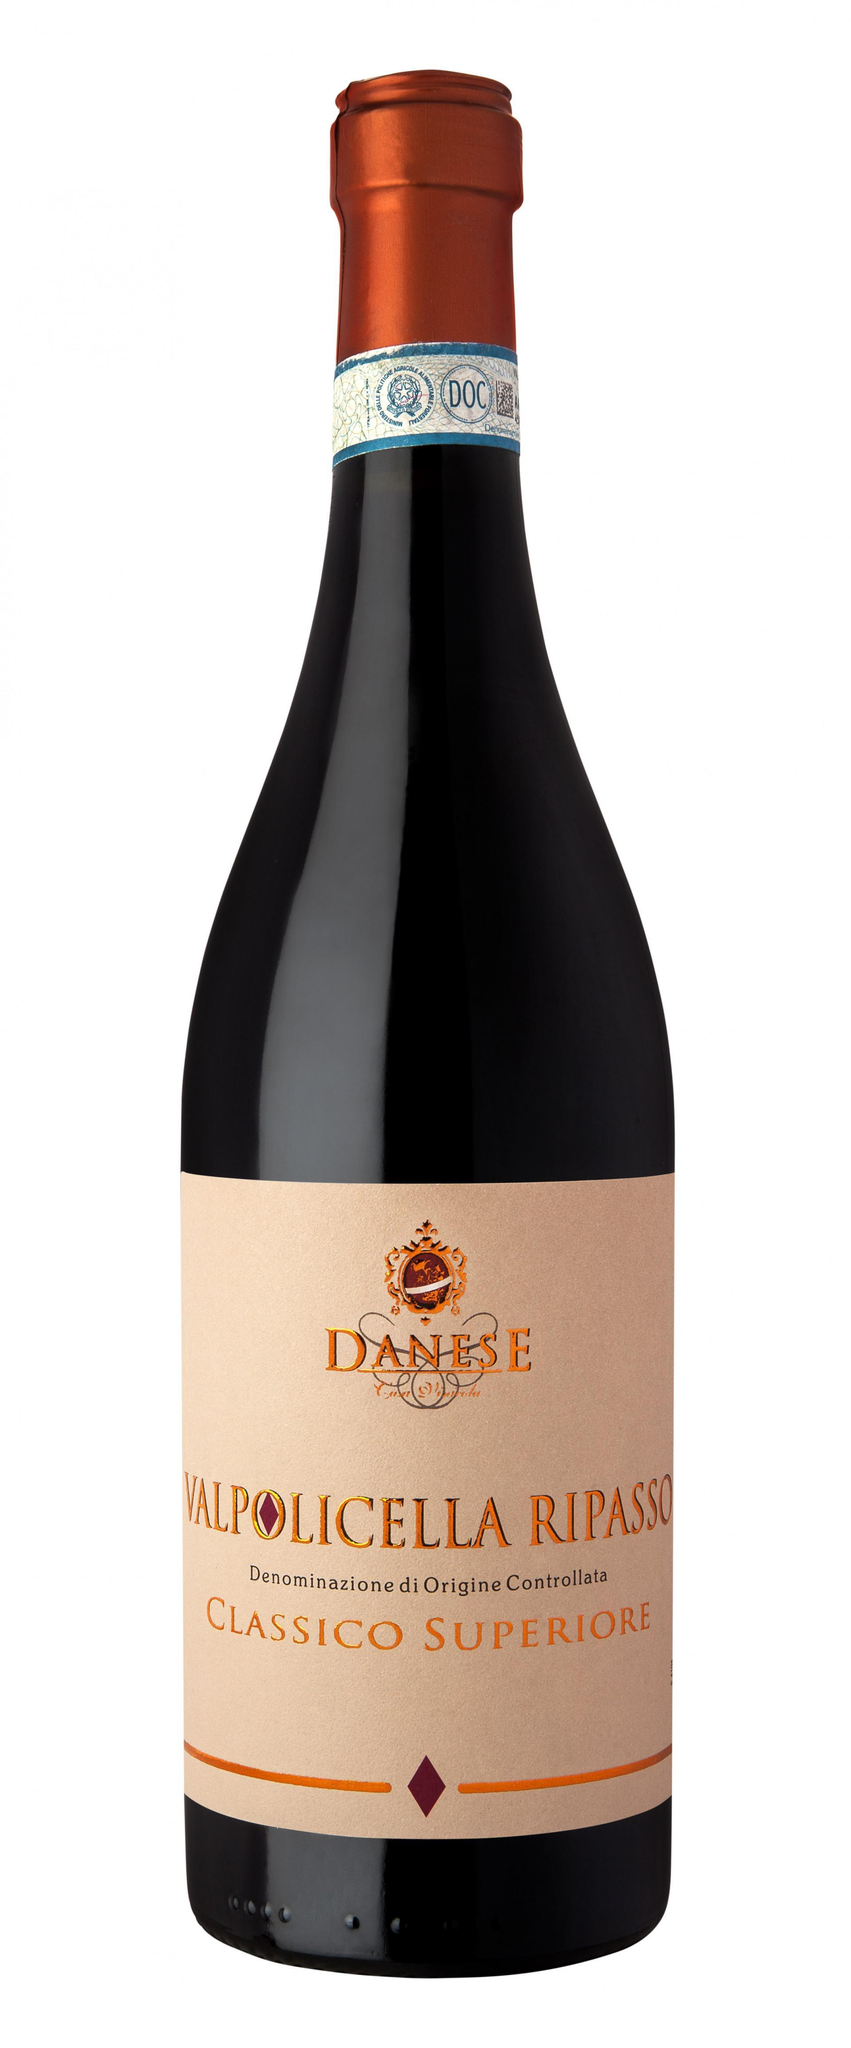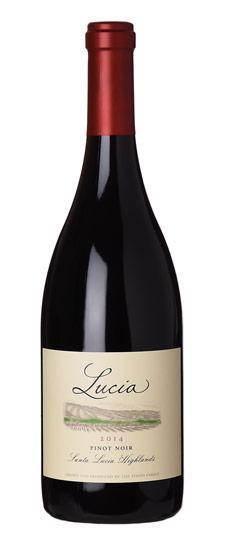The first image is the image on the left, the second image is the image on the right. Analyze the images presented: Is the assertion "One image contains a horizontal row of three wine bottles." valid? Answer yes or no. No. The first image is the image on the left, the second image is the image on the right. Analyze the images presented: Is the assertion "There are fewer than 4 bottles across both images." valid? Answer yes or no. Yes. 